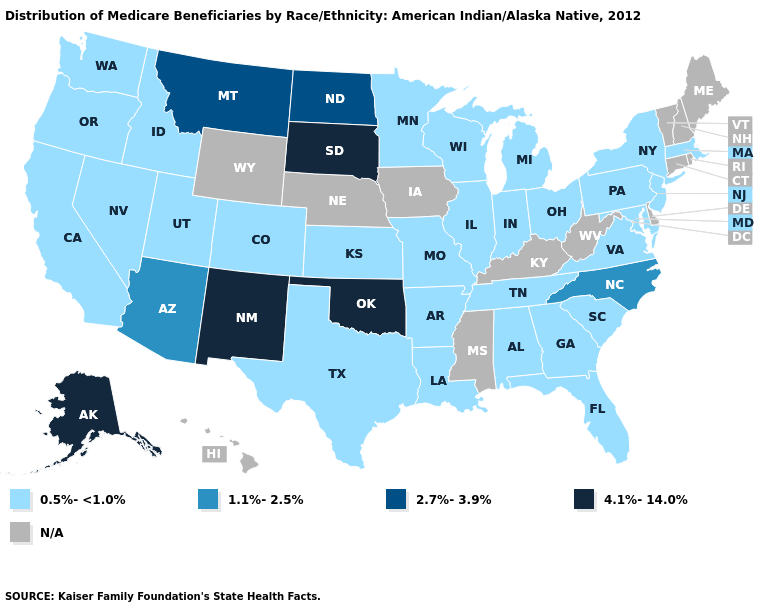Name the states that have a value in the range 1.1%-2.5%?
Quick response, please. Arizona, North Carolina. Does Virginia have the highest value in the South?
Quick response, please. No. Which states have the lowest value in the MidWest?
Quick response, please. Illinois, Indiana, Kansas, Michigan, Minnesota, Missouri, Ohio, Wisconsin. What is the highest value in states that border Kentucky?
Concise answer only. 0.5%-<1.0%. What is the highest value in states that border Wyoming?
Write a very short answer. 4.1%-14.0%. What is the value of New Jersey?
Answer briefly. 0.5%-<1.0%. Name the states that have a value in the range 1.1%-2.5%?
Give a very brief answer. Arizona, North Carolina. What is the lowest value in the USA?
Be succinct. 0.5%-<1.0%. Does the first symbol in the legend represent the smallest category?
Answer briefly. Yes. Name the states that have a value in the range 0.5%-<1.0%?
Keep it brief. Alabama, Arkansas, California, Colorado, Florida, Georgia, Idaho, Illinois, Indiana, Kansas, Louisiana, Maryland, Massachusetts, Michigan, Minnesota, Missouri, Nevada, New Jersey, New York, Ohio, Oregon, Pennsylvania, South Carolina, Tennessee, Texas, Utah, Virginia, Washington, Wisconsin. What is the value of Wyoming?
Quick response, please. N/A. Which states have the lowest value in the USA?
Concise answer only. Alabama, Arkansas, California, Colorado, Florida, Georgia, Idaho, Illinois, Indiana, Kansas, Louisiana, Maryland, Massachusetts, Michigan, Minnesota, Missouri, Nevada, New Jersey, New York, Ohio, Oregon, Pennsylvania, South Carolina, Tennessee, Texas, Utah, Virginia, Washington, Wisconsin. Is the legend a continuous bar?
Write a very short answer. No. Name the states that have a value in the range 0.5%-<1.0%?
Answer briefly. Alabama, Arkansas, California, Colorado, Florida, Georgia, Idaho, Illinois, Indiana, Kansas, Louisiana, Maryland, Massachusetts, Michigan, Minnesota, Missouri, Nevada, New Jersey, New York, Ohio, Oregon, Pennsylvania, South Carolina, Tennessee, Texas, Utah, Virginia, Washington, Wisconsin. 